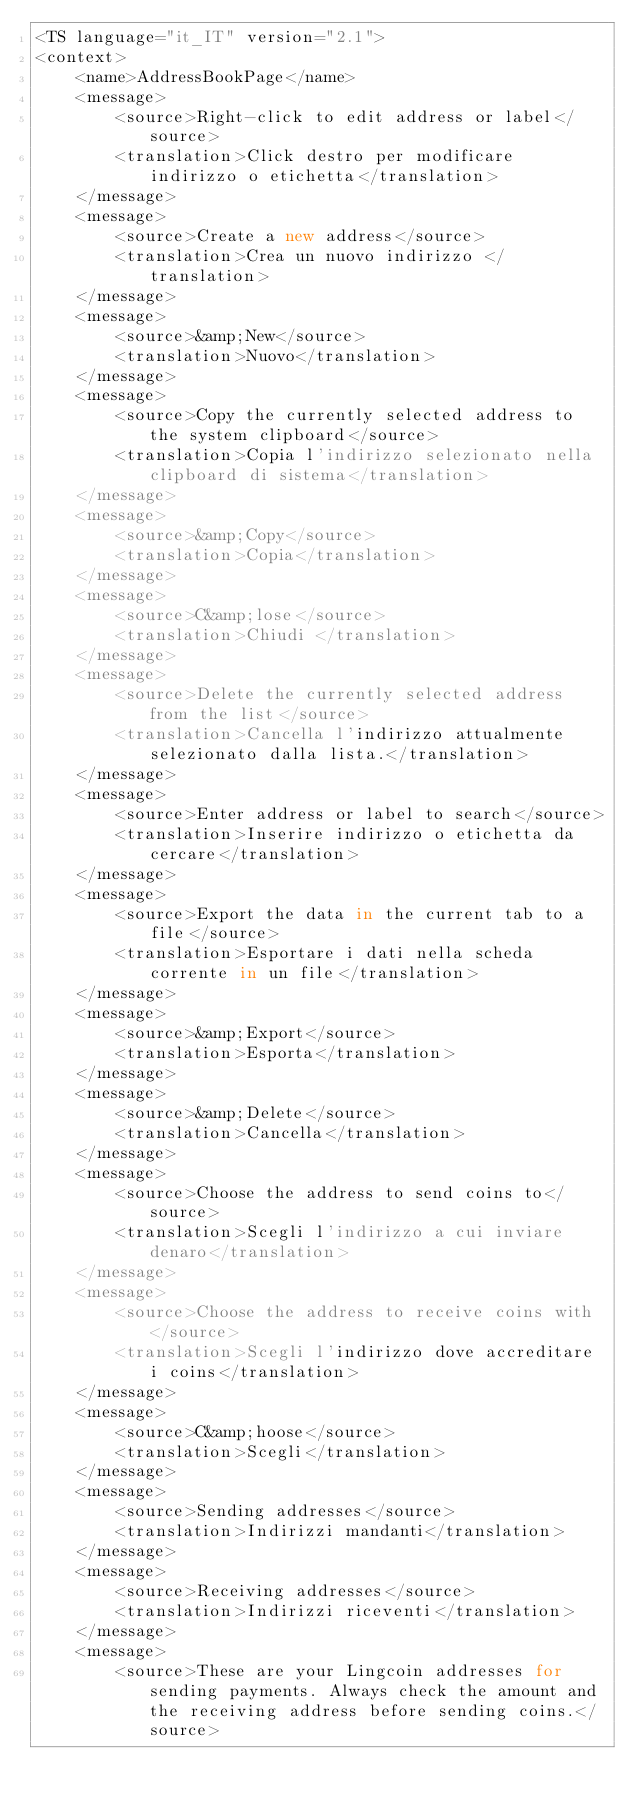<code> <loc_0><loc_0><loc_500><loc_500><_TypeScript_><TS language="it_IT" version="2.1">
<context>
    <name>AddressBookPage</name>
    <message>
        <source>Right-click to edit address or label</source>
        <translation>Click destro per modificare indirizzo o etichetta</translation>
    </message>
    <message>
        <source>Create a new address</source>
        <translation>Crea un nuovo indirizzo </translation>
    </message>
    <message>
        <source>&amp;New</source>
        <translation>Nuovo</translation>
    </message>
    <message>
        <source>Copy the currently selected address to the system clipboard</source>
        <translation>Copia l'indirizzo selezionato nella clipboard di sistema</translation>
    </message>
    <message>
        <source>&amp;Copy</source>
        <translation>Copia</translation>
    </message>
    <message>
        <source>C&amp;lose</source>
        <translation>Chiudi </translation>
    </message>
    <message>
        <source>Delete the currently selected address from the list</source>
        <translation>Cancella l'indirizzo attualmente selezionato dalla lista.</translation>
    </message>
    <message>
        <source>Enter address or label to search</source>
        <translation>Inserire indirizzo o etichetta da cercare</translation>
    </message>
    <message>
        <source>Export the data in the current tab to a file</source>
        <translation>Esportare i dati nella scheda corrente in un file</translation>
    </message>
    <message>
        <source>&amp;Export</source>
        <translation>Esporta</translation>
    </message>
    <message>
        <source>&amp;Delete</source>
        <translation>Cancella</translation>
    </message>
    <message>
        <source>Choose the address to send coins to</source>
        <translation>Scegli l'indirizzo a cui inviare denaro</translation>
    </message>
    <message>
        <source>Choose the address to receive coins with</source>
        <translation>Scegli l'indirizzo dove accreditare i coins</translation>
    </message>
    <message>
        <source>C&amp;hoose</source>
        <translation>Scegli</translation>
    </message>
    <message>
        <source>Sending addresses</source>
        <translation>Indirizzi mandanti</translation>
    </message>
    <message>
        <source>Receiving addresses</source>
        <translation>Indirizzi riceventi</translation>
    </message>
    <message>
        <source>These are your Lingcoin addresses for sending payments. Always check the amount and the receiving address before sending coins.</source></code> 